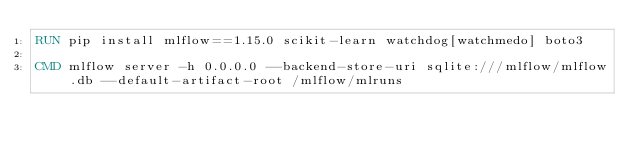<code> <loc_0><loc_0><loc_500><loc_500><_Dockerfile_>RUN pip install mlflow==1.15.0 scikit-learn watchdog[watchmedo] boto3

CMD mlflow server -h 0.0.0.0 --backend-store-uri sqlite:///mlflow/mlflow.db --default-artifact-root /mlflow/mlruns


</code> 